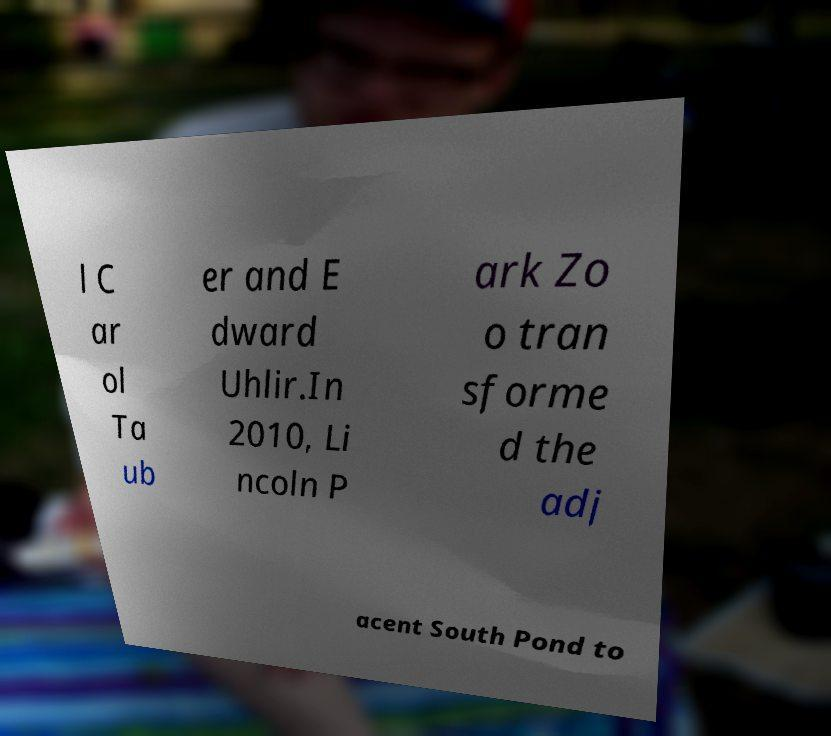Please read and relay the text visible in this image. What does it say? l C ar ol Ta ub er and E dward Uhlir.In 2010, Li ncoln P ark Zo o tran sforme d the adj acent South Pond to 